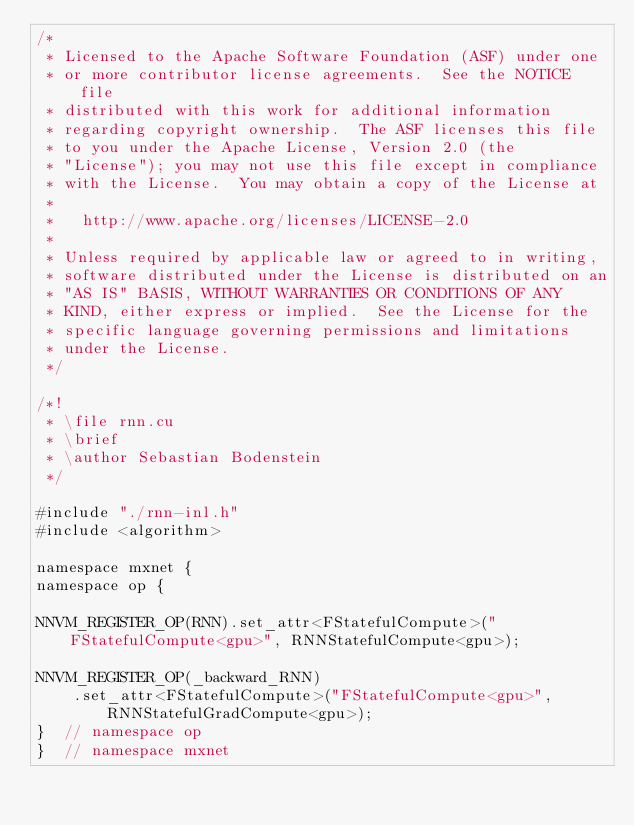<code> <loc_0><loc_0><loc_500><loc_500><_Cuda_>/*
 * Licensed to the Apache Software Foundation (ASF) under one
 * or more contributor license agreements.  See the NOTICE file
 * distributed with this work for additional information
 * regarding copyright ownership.  The ASF licenses this file
 * to you under the Apache License, Version 2.0 (the
 * "License"); you may not use this file except in compliance
 * with the License.  You may obtain a copy of the License at
 *
 *   http://www.apache.org/licenses/LICENSE-2.0
 *
 * Unless required by applicable law or agreed to in writing,
 * software distributed under the License is distributed on an
 * "AS IS" BASIS, WITHOUT WARRANTIES OR CONDITIONS OF ANY
 * KIND, either express or implied.  See the License for the
 * specific language governing permissions and limitations
 * under the License.
 */

/*!
 * \file rnn.cu
 * \brief
 * \author Sebastian Bodenstein
 */

#include "./rnn-inl.h"
#include <algorithm>

namespace mxnet {
namespace op {

NNVM_REGISTER_OP(RNN).set_attr<FStatefulCompute>("FStatefulCompute<gpu>", RNNStatefulCompute<gpu>);

NNVM_REGISTER_OP(_backward_RNN)
    .set_attr<FStatefulCompute>("FStatefulCompute<gpu>", RNNStatefulGradCompute<gpu>);
}  // namespace op
}  // namespace mxnet
</code> 